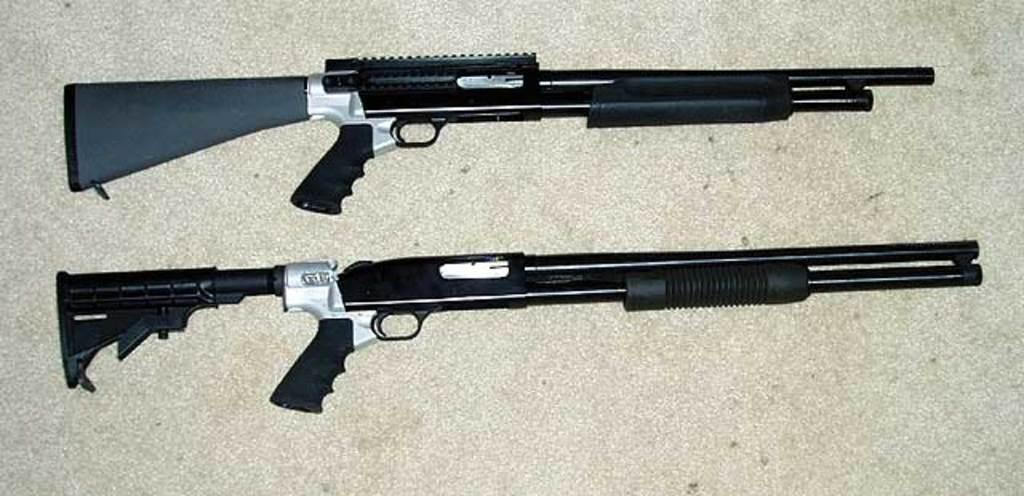What objects are present on the table in the image? There are guns on a table in the image. Where is the table located in the image? The table is in the center of the image. What type of pin is used to hold the volleyball in the image? There is no volleyball present in the image, and therefore no pin is used to hold it. What occasion is being celebrated in the image? There is no indication of a birthday or any other occasion being celebrated in the image. 